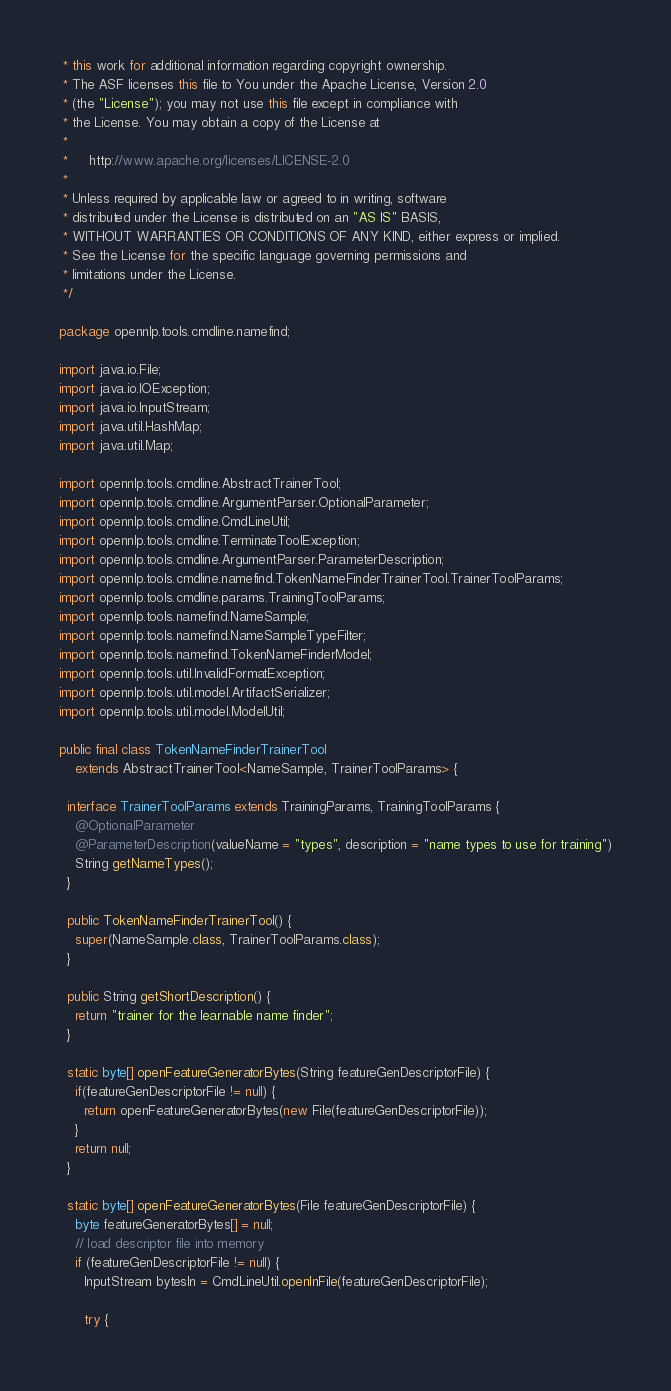Convert code to text. <code><loc_0><loc_0><loc_500><loc_500><_Java_> * this work for additional information regarding copyright ownership.
 * The ASF licenses this file to You under the Apache License, Version 2.0
 * (the "License"); you may not use this file except in compliance with
 * the License. You may obtain a copy of the License at
 *
 *     http://www.apache.org/licenses/LICENSE-2.0
 *
 * Unless required by applicable law or agreed to in writing, software
 * distributed under the License is distributed on an "AS IS" BASIS,
 * WITHOUT WARRANTIES OR CONDITIONS OF ANY KIND, either express or implied.
 * See the License for the specific language governing permissions and
 * limitations under the License.
 */

package opennlp.tools.cmdline.namefind;

import java.io.File;
import java.io.IOException;
import java.io.InputStream;
import java.util.HashMap;
import java.util.Map;

import opennlp.tools.cmdline.AbstractTrainerTool;
import opennlp.tools.cmdline.ArgumentParser.OptionalParameter;
import opennlp.tools.cmdline.CmdLineUtil;
import opennlp.tools.cmdline.TerminateToolException;
import opennlp.tools.cmdline.ArgumentParser.ParameterDescription;
import opennlp.tools.cmdline.namefind.TokenNameFinderTrainerTool.TrainerToolParams;
import opennlp.tools.cmdline.params.TrainingToolParams;
import opennlp.tools.namefind.NameSample;
import opennlp.tools.namefind.NameSampleTypeFilter;
import opennlp.tools.namefind.TokenNameFinderModel;
import opennlp.tools.util.InvalidFormatException;
import opennlp.tools.util.model.ArtifactSerializer;
import opennlp.tools.util.model.ModelUtil;

public final class TokenNameFinderTrainerTool
    extends AbstractTrainerTool<NameSample, TrainerToolParams> {
  
  interface TrainerToolParams extends TrainingParams, TrainingToolParams {
    @OptionalParameter
    @ParameterDescription(valueName = "types", description = "name types to use for training")
    String getNameTypes();
  }

  public TokenNameFinderTrainerTool() {
    super(NameSample.class, TrainerToolParams.class);
  }

  public String getShortDescription() {
    return "trainer for the learnable name finder";
  }
  
  static byte[] openFeatureGeneratorBytes(String featureGenDescriptorFile) {
    if(featureGenDescriptorFile != null) {
      return openFeatureGeneratorBytes(new File(featureGenDescriptorFile));
    }
    return null;
  }
  
  static byte[] openFeatureGeneratorBytes(File featureGenDescriptorFile) {
    byte featureGeneratorBytes[] = null;
    // load descriptor file into memory
    if (featureGenDescriptorFile != null) {
      InputStream bytesIn = CmdLineUtil.openInFile(featureGenDescriptorFile);

      try {</code> 